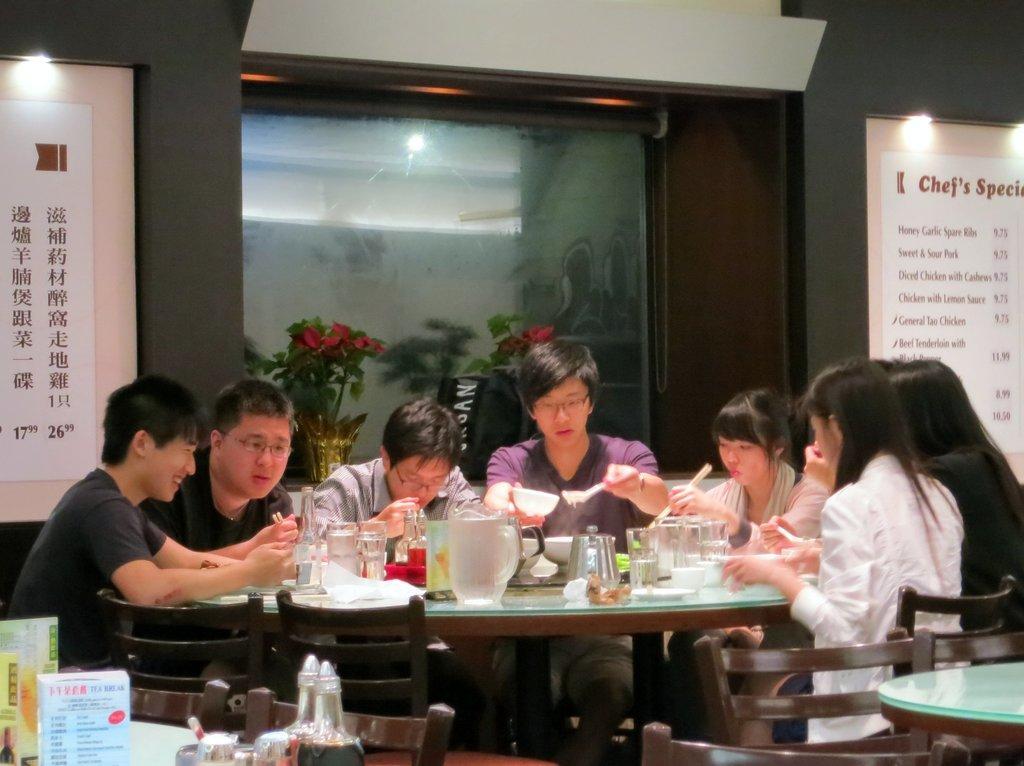Can you describe this image briefly? I think this picture is taken in a restaurant. There are group of people sitting a table. On the table there are some glasses, jar and bowls. Towards the right there are table and chairs. In the background there is a board, plants and lights. On the board there is some text. 